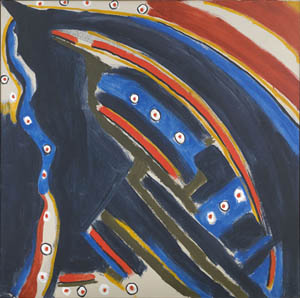What emotions does this image evoke? The image evokes a range of emotions, from mystery and intrigue to a sense of cosmic wonder. The dark background might invoke a feeling of the unknown, while the scattered dots reminiscent of stars can inspire a sense of awe and contemplation. The bold use of colors could also evoke feelings of excitement and energy, spurring the viewer's imagination. Can you provide a backstory for what this abstract shape might represent? Imagine this abstract shape as a representation of a mystical creature, soaring across an ethereal night sky. It is an ancient being, known in folklore as the 'Guardian of The Stars.' According to legends, this creature emerges only during the darkest nights to protect the stars from falling into the void. The dots surrounding it are the stars it guards, each representing a dream or a wish made by a wandering soul. The swirling colors are trails of cosmic energy, left in the wake of its majestic flight. 